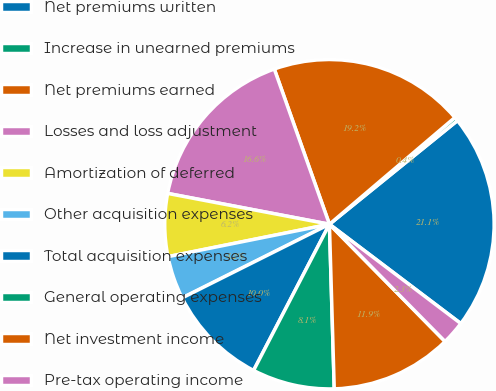<chart> <loc_0><loc_0><loc_500><loc_500><pie_chart><fcel>Net premiums written<fcel>Increase in unearned premiums<fcel>Net premiums earned<fcel>Losses and loss adjustment<fcel>Amortization of deferred<fcel>Other acquisition expenses<fcel>Total acquisition expenses<fcel>General operating expenses<fcel>Net investment income<fcel>Pre-tax operating income<nl><fcel>21.13%<fcel>0.39%<fcel>19.21%<fcel>16.57%<fcel>6.15%<fcel>4.23%<fcel>10.0%<fcel>8.08%<fcel>11.92%<fcel>2.31%<nl></chart> 